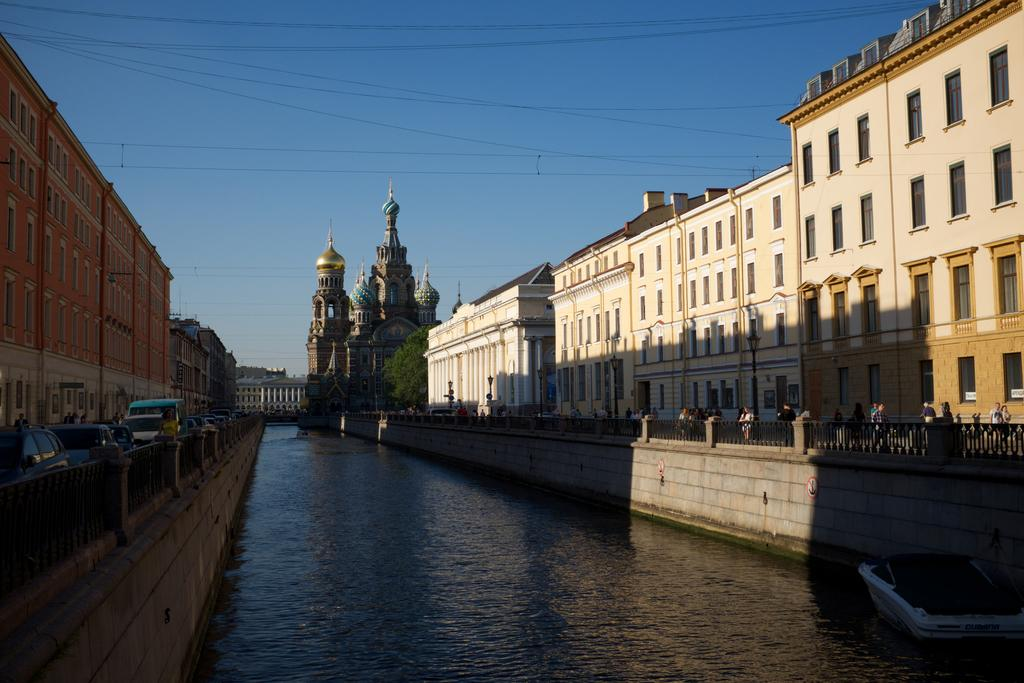What can be seen in the sky in the image? The sky is visible in the image, but no specific details about the sky are mentioned in the facts. What type of structures are present in the image? There are buildings in the image. What are some features of the buildings? Windows are present in the image, which suggests that the buildings have windows. What else can be seen in the image besides buildings? There is water visible in the image, as well as wires, fences, vehicles, and people. Can you describe the vehicles in the image? The facts do not provide specific details about the vehicles, so we cannot describe them. What type of shirt is the appliance wearing in the image? There is no appliance present in the image, and therefore no shirt or any clothing item can be associated with it. 